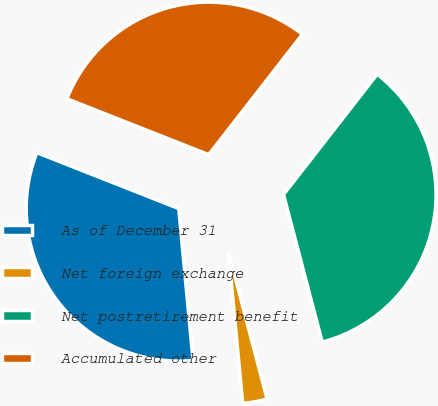Convert chart to OTSL. <chart><loc_0><loc_0><loc_500><loc_500><pie_chart><fcel>As of December 31<fcel>Net foreign exchange<fcel>Net postretirement benefit<fcel>Accumulated other<nl><fcel>32.47%<fcel>2.59%<fcel>35.39%<fcel>29.55%<nl></chart> 